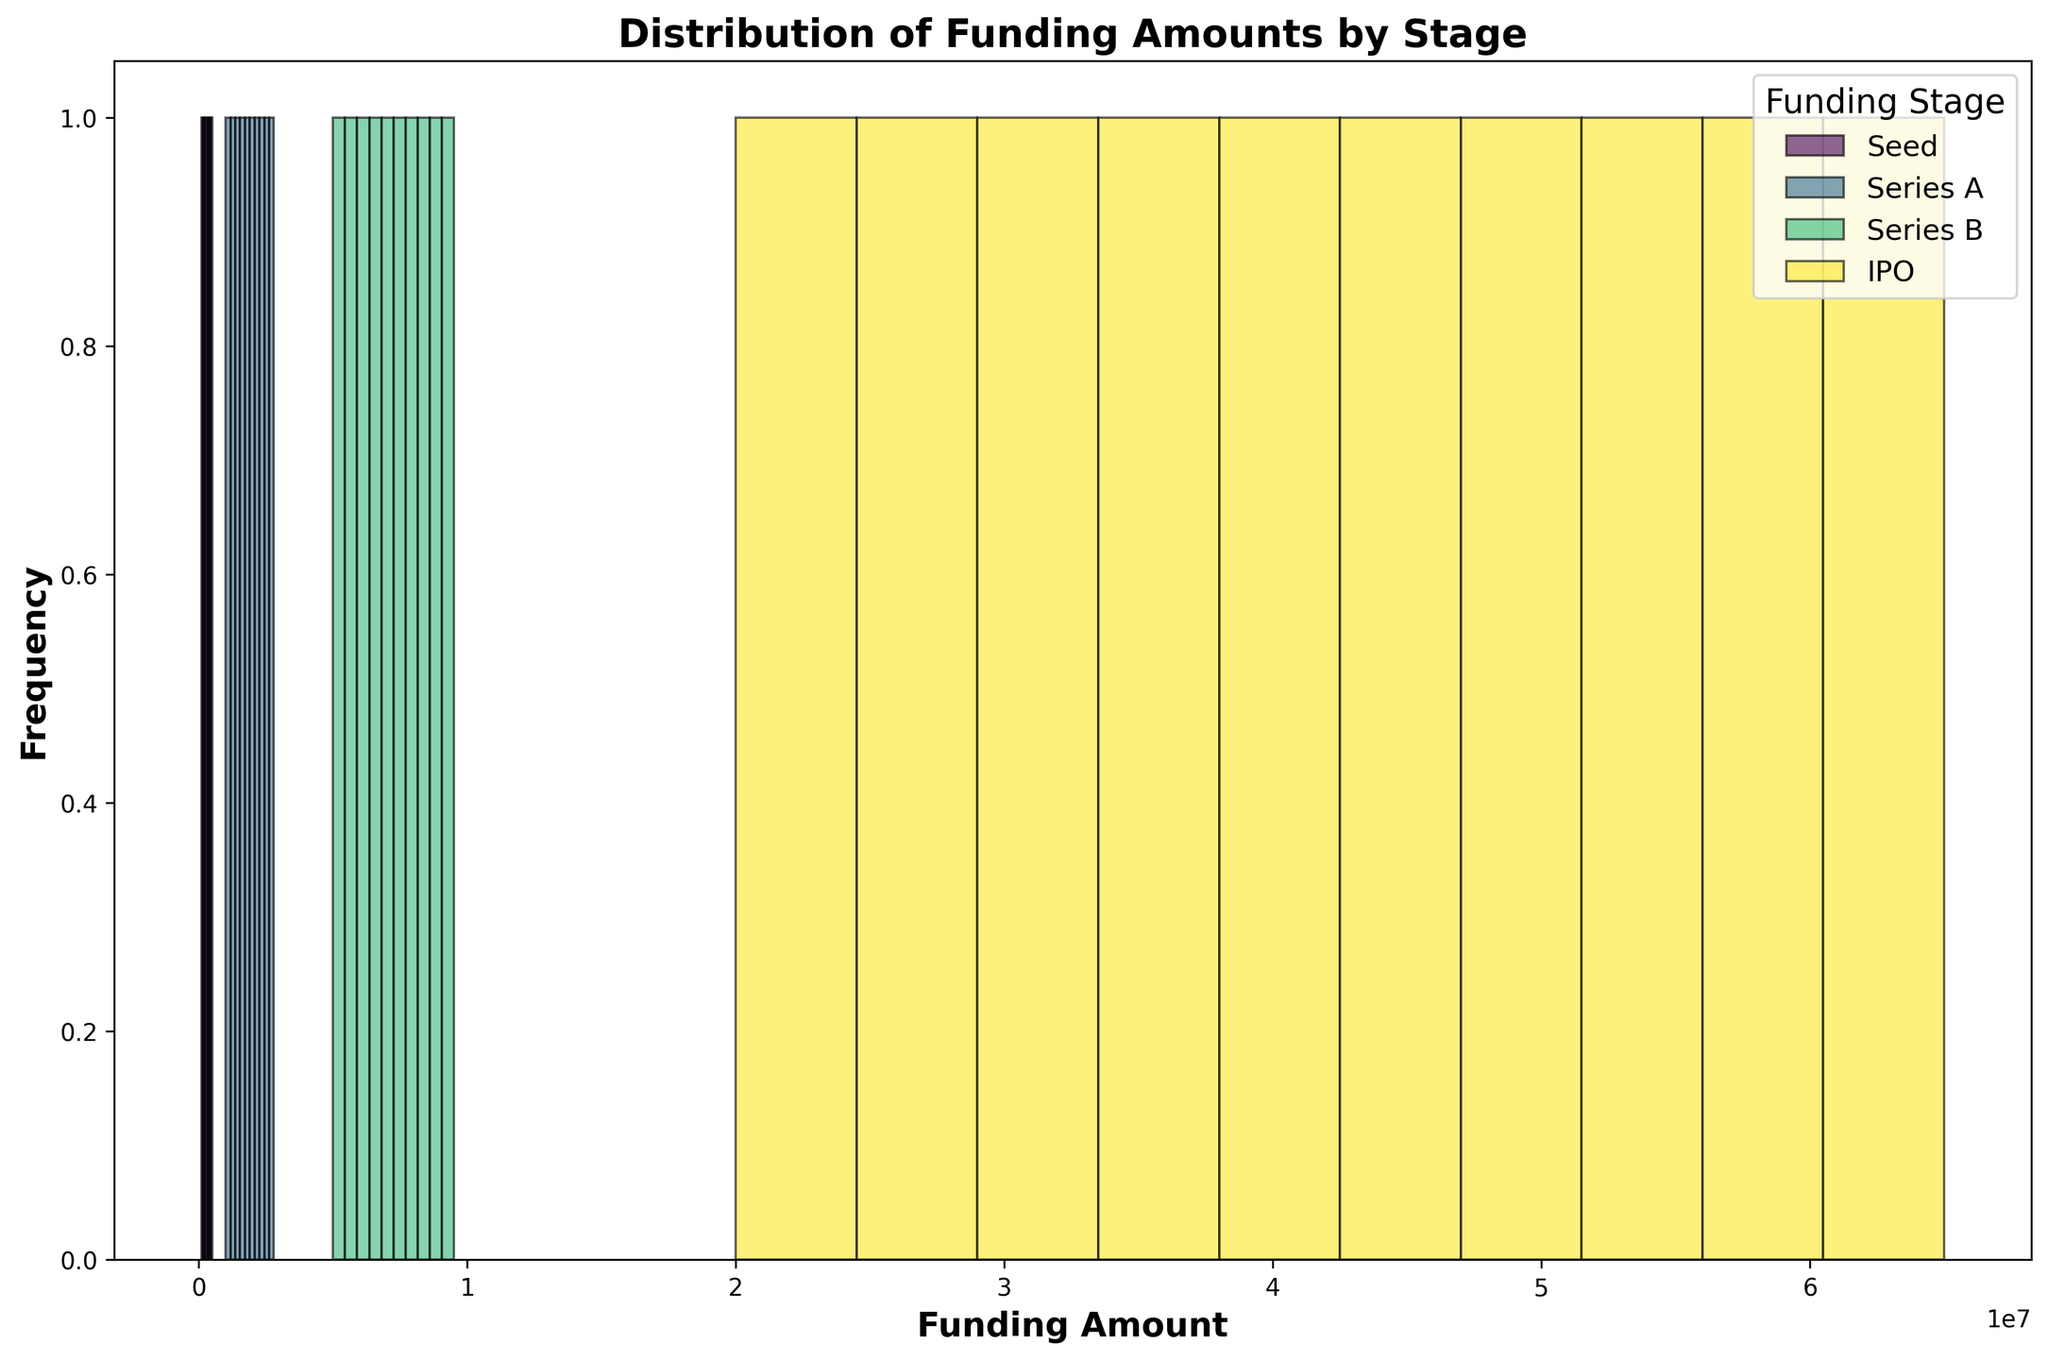What stage has the highest maximum funding amount? The highest maximum funding amount can be visually identified by looking at the histogram bars that extend the furthest to the right. The IPO stage’s bars extend further right compared to others, indicating higher funding amounts.
Answer: IPO What is the funding range for the Seed stage? To determine the range, look at the start and end of the bars in the Seed stage. The bars for the Seed stage start at $100,000 and end at $500,000, so the range is $500,000 - $100,000.
Answer: $400,000 Which stage has the most frequent funding amounts between $200,000 and $500,000? Identify which stage's histogram bars appear most frequently within the $200,000 to $500,000 range. The Seed stage has multiple bars within this range, while other stages do not.
Answer: Seed For Series A, is the distribution more spread out or clustered around a central value? Examining the Series A histogram bars shows whether they are evenly spread out or clustered. Series A funding amounts have bars that are closely spaced in the range of $1,000,000 to $2,800,000, indicating a clustered distribution.
Answer: Clustered Which funding stage has the least overlap with other stages concerning their funding amounts? Visualize which stage's bars overlap the least with the bars of other stages. IPO funding amounts are significantly higher and more isolated than other stages, with minimal overlap.
Answer: IPO How does the frequency of $20,000,000 funding differ between Series B and IPO stages? Count the bars and their heights around the $20,000,000 mark for both Series B and IPO. Series B has no bars in the $20,000,000 range, while IPO has bars around this amount.
Answer: Only IPO has bars around $20,000,000 What is the most common funding range for Series B? The Series B stage's most frequent funding range is identified by the tallest bars within it. The highest bars for Series B are within the $5,000,000 to $9,500,000 range.
Answer: $5,000,000 to $9,500,000 Which funding stage shows the greatest variability in funding amounts? Assess the spread of the bars' lengths within each stage to determine the variability. IPO stage has a wide range of funding amounts ($20,000,000 to $65,000,000), showing the greatest variability.
Answer: IPO Compare the average funding amounts between Seed and Series A stages. Calculate the average by summing the data points for each stage and dividing by the number of points. For Seed: average = ($100,000 + $150,000 + $200,000 + $250,000 + $300,000 + $350,000 + $400,000 + $450,000 + $500,000) / 9 = $300,000. For Series A: average = ($1,000,000 + $1,200,000 + $1,400,000 + $1,600,000 + $1,800,000 + $2,000,000 + $2,200,000 + $2,400,000 + $2,600,000 + $2,800,000) / 10 = $1,900,000.
Answer: Seed: $300,000, Series A: $1,900,000 Does the IPO stage dominate in terms of available funding amounts? Determine dominance by comparing the height and spread of IPO bars relative to other stages. IPO stage consistently has higher funding amounts and a more significant spread range compared to all other stages.
Answer: Yes 